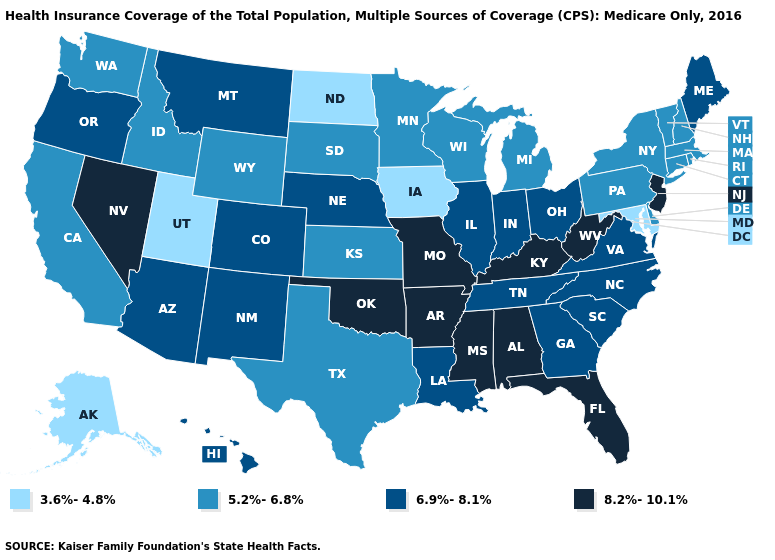Among the states that border Connecticut , which have the highest value?
Answer briefly. Massachusetts, New York, Rhode Island. What is the value of Michigan?
Write a very short answer. 5.2%-6.8%. Among the states that border Washington , does Oregon have the highest value?
Give a very brief answer. Yes. Does the map have missing data?
Answer briefly. No. Name the states that have a value in the range 6.9%-8.1%?
Answer briefly. Arizona, Colorado, Georgia, Hawaii, Illinois, Indiana, Louisiana, Maine, Montana, Nebraska, New Mexico, North Carolina, Ohio, Oregon, South Carolina, Tennessee, Virginia. Which states have the highest value in the USA?
Be succinct. Alabama, Arkansas, Florida, Kentucky, Mississippi, Missouri, Nevada, New Jersey, Oklahoma, West Virginia. Which states have the highest value in the USA?
Concise answer only. Alabama, Arkansas, Florida, Kentucky, Mississippi, Missouri, Nevada, New Jersey, Oklahoma, West Virginia. How many symbols are there in the legend?
Answer briefly. 4. Does Mississippi have the lowest value in the USA?
Give a very brief answer. No. Name the states that have a value in the range 6.9%-8.1%?
Keep it brief. Arizona, Colorado, Georgia, Hawaii, Illinois, Indiana, Louisiana, Maine, Montana, Nebraska, New Mexico, North Carolina, Ohio, Oregon, South Carolina, Tennessee, Virginia. What is the value of Indiana?
Quick response, please. 6.9%-8.1%. Which states hav the highest value in the South?
Give a very brief answer. Alabama, Arkansas, Florida, Kentucky, Mississippi, Oklahoma, West Virginia. What is the value of New Jersey?
Give a very brief answer. 8.2%-10.1%. Among the states that border Wyoming , which have the lowest value?
Quick response, please. Utah. 